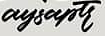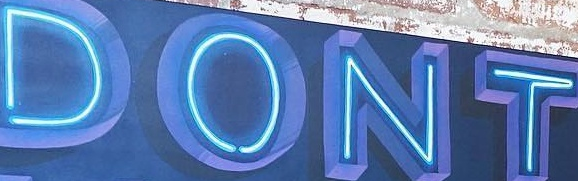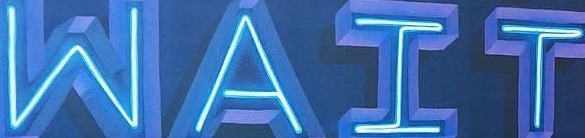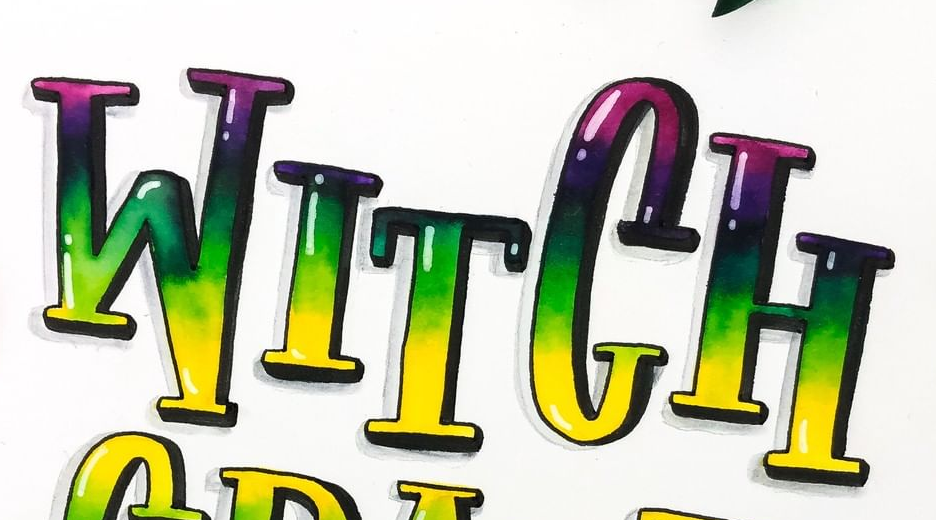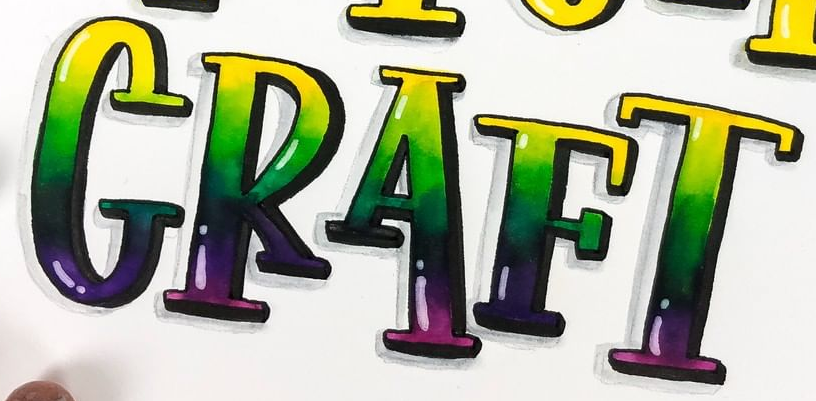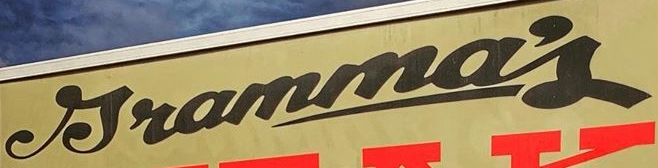What words are shown in these images in order, separated by a semicolon? aysaptr; DONT; WAIT; WITCH; CRAFT; Jramma's 